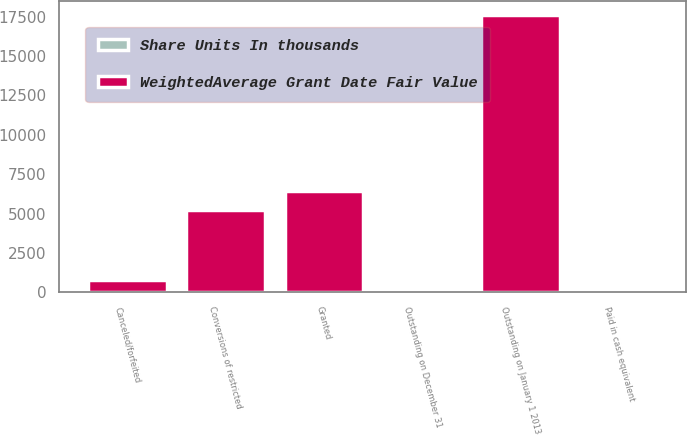Convert chart. <chart><loc_0><loc_0><loc_500><loc_500><stacked_bar_chart><ecel><fcel>Outstanding on January 1 2013<fcel>Granted<fcel>Conversions of restricted<fcel>Paid in cash equivalent<fcel>Canceled/forfeited<fcel>Outstanding on December 31<nl><fcel>WeightedAverage Grant Date Fair Value<fcel>17584<fcel>6425<fcel>5220<fcel>55<fcel>760<fcel>32.67<nl><fcel>Share Units In thousands<fcel>28.01<fcel>32.67<fcel>25.17<fcel>32.25<fcel>30.33<fcel>30.41<nl></chart> 